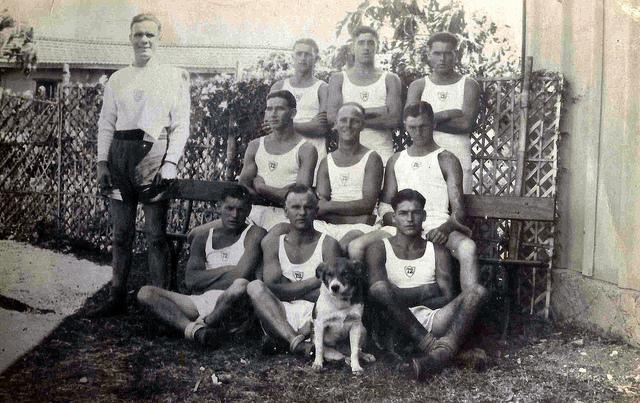What type of tops are the men on the right wearing?

Choices:
A) skinny tops
B) crop tops
C) big tops
D) tank tops tank tops 